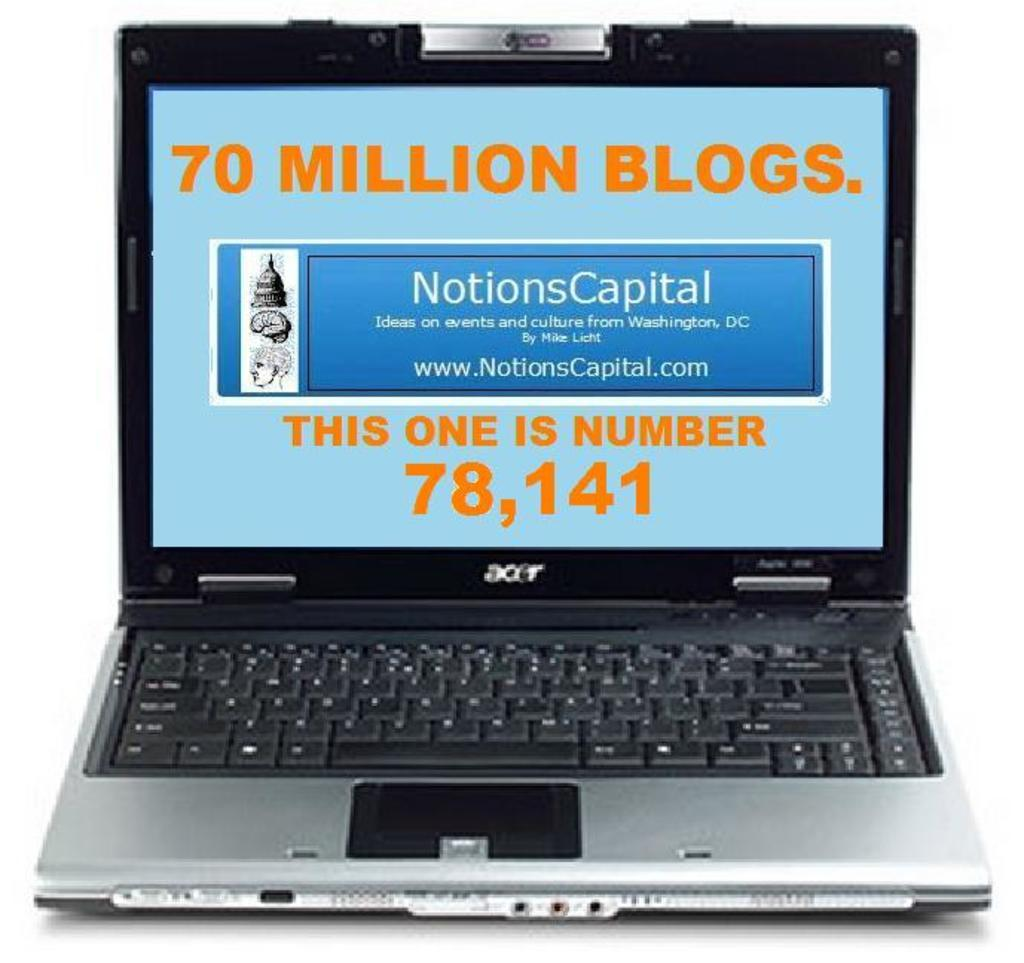Provide a one-sentence caption for the provided image. An acer laptop with a fake screen showing 70 million blogs and a link to a website. 